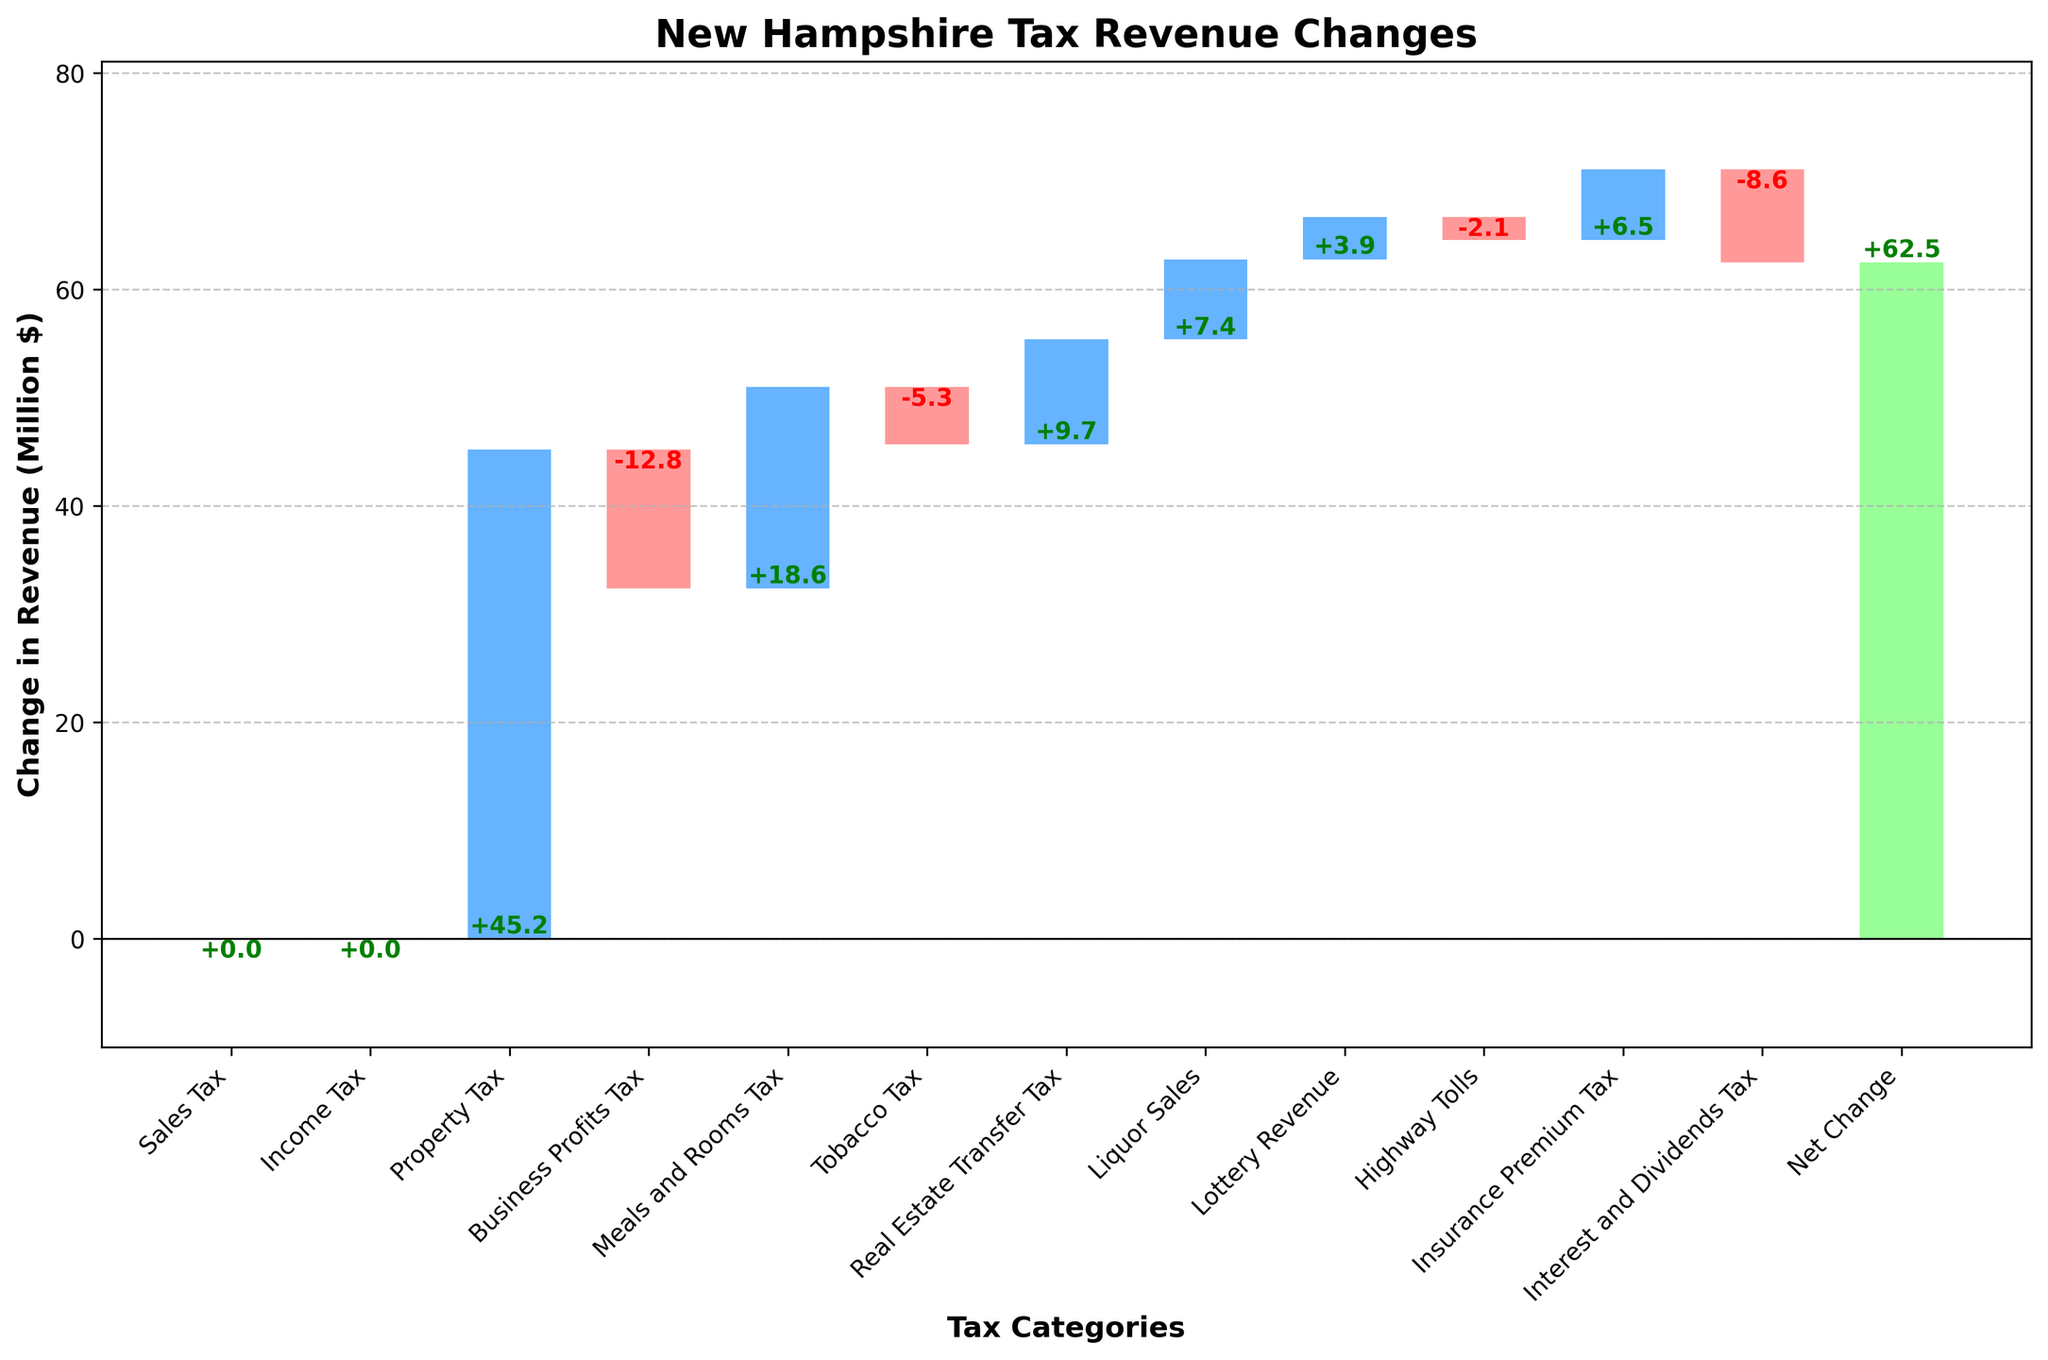What's the title of the figure? The title of a figure is usually found at the top and describes the main subject of the chart. Here, it reads "New Hampshire Tax Revenue Changes".
Answer: New Hampshire Tax Revenue Changes Which tax category had the highest positive change? Inspect the heights of the bars above the baseline (0). The highest bar indicates the largest positive change. For this chart, the Property Tax bar is the tallest.
Answer: Property Tax Which tax category experienced the greatest decline? Look for the bar with the largest drop below the baseline (0). The deeper the bar, the greater the decline. Business Profits Tax has the deepest bar.
Answer: Business Profits Tax What is the net change in tax revenue? The final bar on the right represents the net change. Read the label associated with this bar, which shows +62.5.
Answer: +62.5 How much did the Meals and Rooms Tax increase by? Locate the bar labeled "Meals and Rooms Tax" and check its value. The label shows an increase of +18.6.
Answer: +18.6 Sum of the revenue changes for sales-related taxes (Sales Tax, Meals and Rooms Tax, Liquor Sales)? Sum the changes for Sales Tax (0), Meals and Rooms Tax (+18.6), and Liquor Sales (+7.4). The total is 0 + 18.6 + 7.4 = 26.
Answer: 26 Which tax category had a change just below the Real Estate Transfer Tax? Identify the bar just below the Real Estate Transfer Tax bar (+9.7) in terms of height above the baseline. The Tobacco Tax at -5.3 is below it visually.
Answer: Tobacco Tax Did the Highway Tolls increase or decrease? Check the Highway Tolls bar. It's below the baseline, indicating a decrease.
Answer: Decrease Compare the changes in Income Tax and Insurance Premium Tax. Which had a higher impact on revenue? Income Tax has 0 change, while Insurance Premium Tax increased by +6.5. Therefore, Insurance Premium Tax had a higher impact.
Answer: Insurance Premium Tax What is the combined change for the Business Profits Tax and Interest and Dividends Tax? Add the values for Business Profits Tax (-12.8) and Interest and Dividends Tax (-8.6). The combined change is -12.8 + (-8.6) = -21.4.
Answer: -21.4 